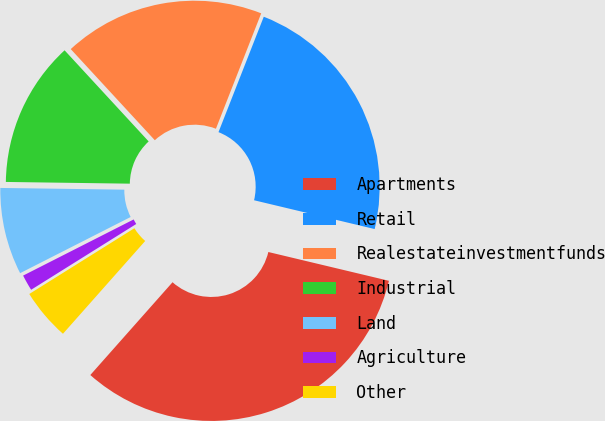<chart> <loc_0><loc_0><loc_500><loc_500><pie_chart><fcel>Apartments<fcel>Retail<fcel>Realestateinvestmentfunds<fcel>Industrial<fcel>Land<fcel>Agriculture<fcel>Other<nl><fcel>32.81%<fcel>22.78%<fcel>17.81%<fcel>12.92%<fcel>7.7%<fcel>1.42%<fcel>4.56%<nl></chart> 